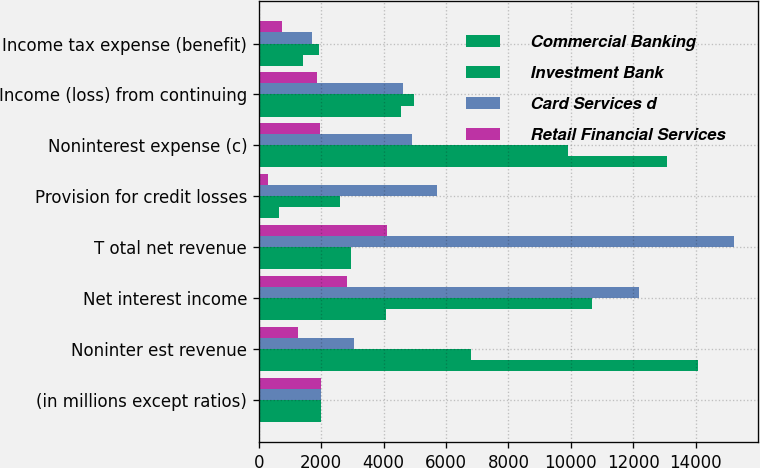Convert chart to OTSL. <chart><loc_0><loc_0><loc_500><loc_500><stacked_bar_chart><ecel><fcel>(in millions except ratios)<fcel>Noninter est revenue<fcel>Net interest income<fcel>T otal net revenue<fcel>Provision for credit losses<fcel>Noninterest expense (c)<fcel>Income (loss) from continuing<fcel>Income tax expense (benefit)<nl><fcel>Commercial Banking<fcel>2007<fcel>14094<fcel>4076<fcel>2943<fcel>654<fcel>13074<fcel>4563<fcel>1424<nl><fcel>Investment Bank<fcel>2007<fcel>6803<fcel>10676<fcel>2943<fcel>2610<fcel>9900<fcel>4969<fcel>1934<nl><fcel>Card Services d<fcel>2007<fcel>3046<fcel>12189<fcel>15235<fcel>5711<fcel>4914<fcel>4610<fcel>1691<nl><fcel>Retail Financial Services<fcel>2007<fcel>1263<fcel>2840<fcel>4103<fcel>279<fcel>1958<fcel>1866<fcel>732<nl></chart> 